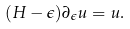<formula> <loc_0><loc_0><loc_500><loc_500>( H - \epsilon ) \partial _ { \epsilon } u = u .</formula> 